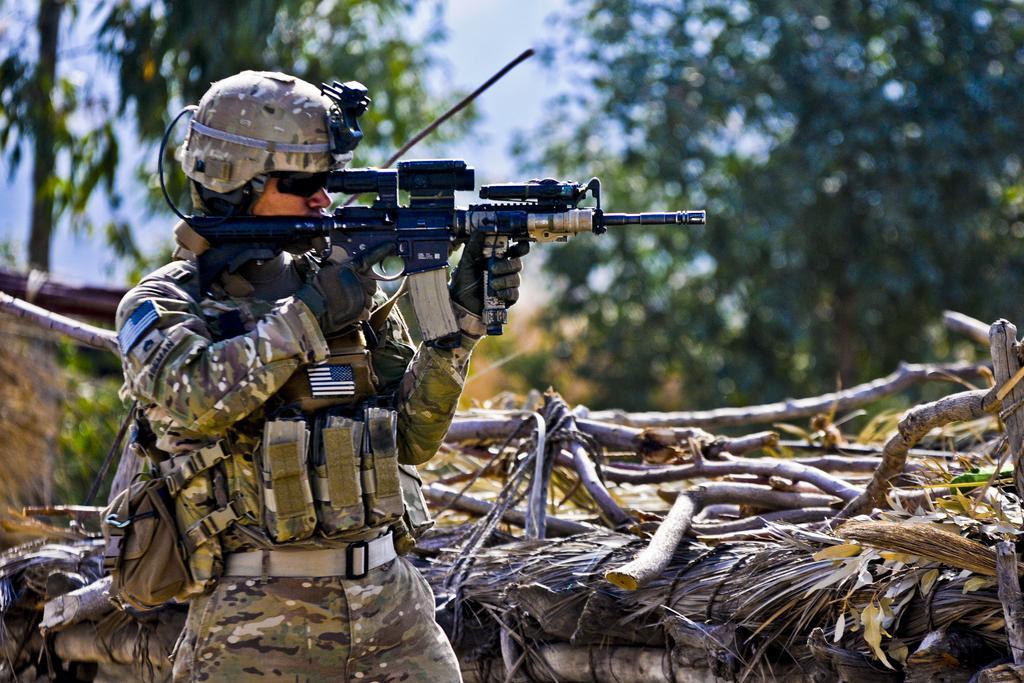How would you summarize this image in a sentence or two? In this image I see a man who is wearing army uniform and I see that he is holding a gun in his hands and I can also see that he is wearing a helmet on his head and I see that he is carrying a bag and I see wooden sticks over here. In the background I see the trees and the sky and I see that it is blurred. 